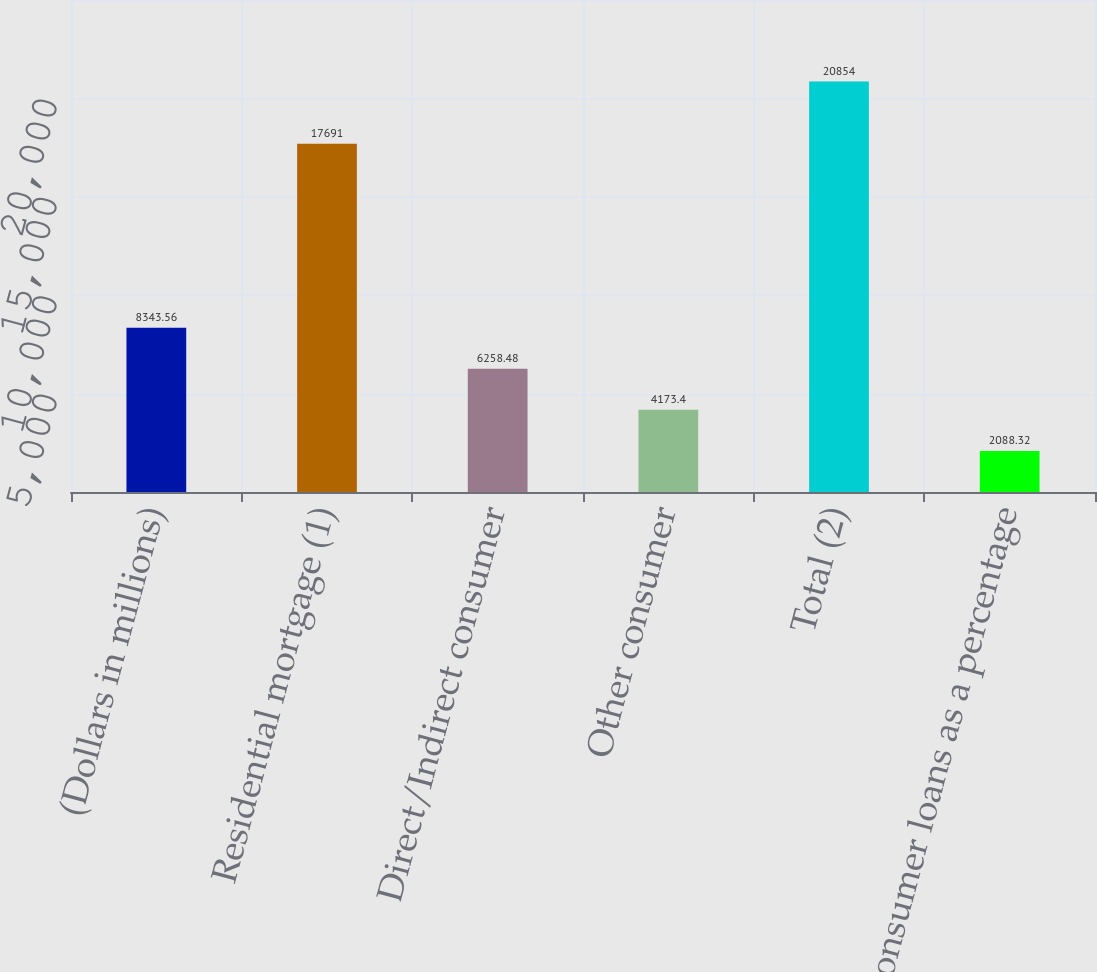Convert chart. <chart><loc_0><loc_0><loc_500><loc_500><bar_chart><fcel>(Dollars in millions)<fcel>Residential mortgage (1)<fcel>Direct/Indirect consumer<fcel>Other consumer<fcel>Total (2)<fcel>Consumer loans as a percentage<nl><fcel>8343.56<fcel>17691<fcel>6258.48<fcel>4173.4<fcel>20854<fcel>2088.32<nl></chart> 